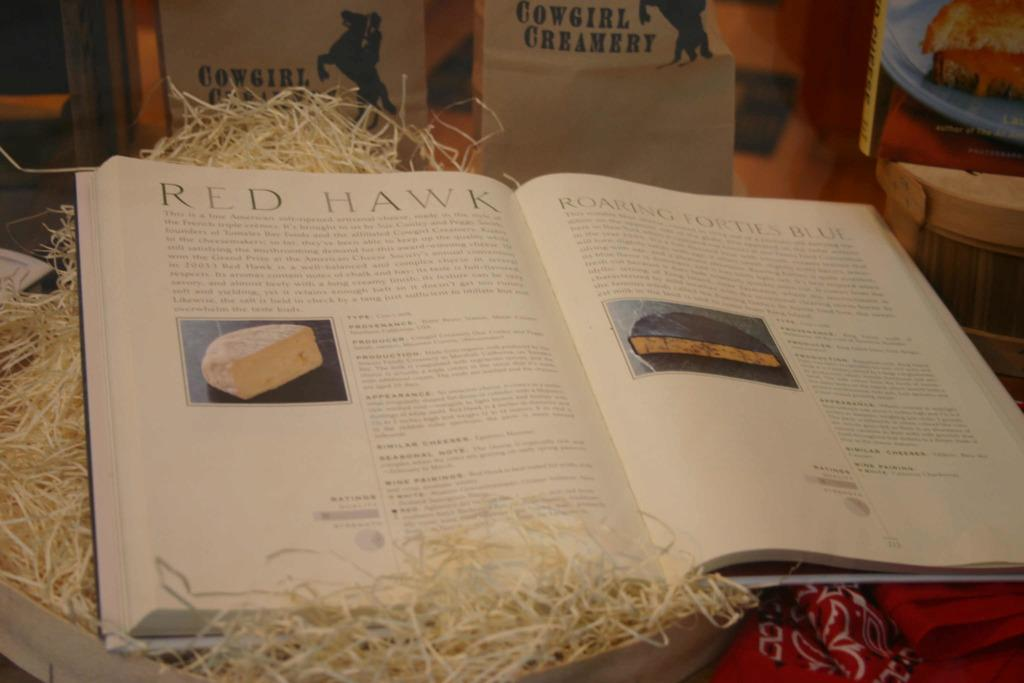<image>
Describe the image concisely. A book about cheese is open to a page titled "Red Hawk". 